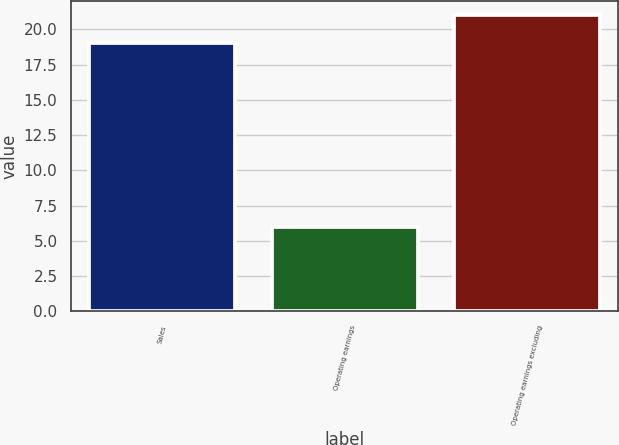Convert chart to OTSL. <chart><loc_0><loc_0><loc_500><loc_500><bar_chart><fcel>Sales<fcel>Operating earnings<fcel>Operating earnings excluding<nl><fcel>19<fcel>6<fcel>21<nl></chart> 